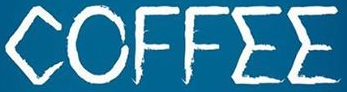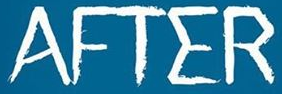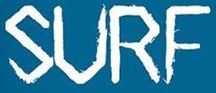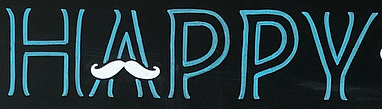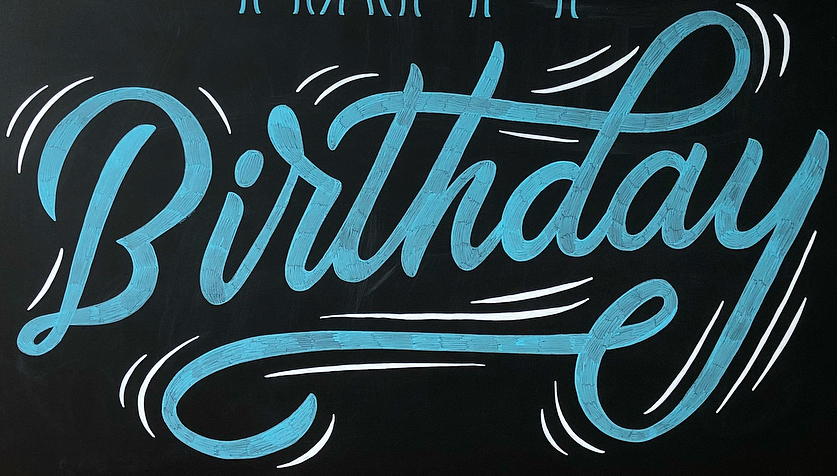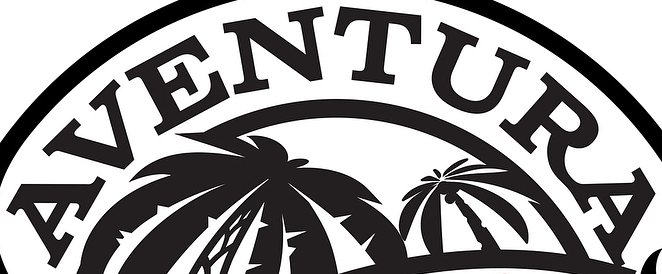Read the text content from these images in order, separated by a semicolon. COFFEE; AFTER; SURF; HAPPY; Birthday; AVENTURA 